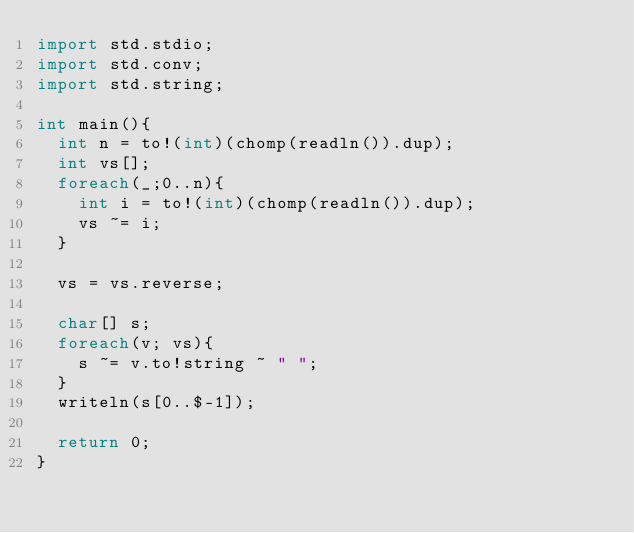<code> <loc_0><loc_0><loc_500><loc_500><_D_>import std.stdio;
import std.conv;
import std.string;

int main(){
	int n = to!(int)(chomp(readln()).dup);
	int vs[];
	foreach(_;0..n){
		int i = to!(int)(chomp(readln()).dup);
		vs ~= i;
	}

	vs = vs.reverse;
	
	char[] s;
	foreach(v; vs){
		s ~= v.to!string ~ " ";
	}
	writeln(s[0..$-1]);

	return 0;
}</code> 